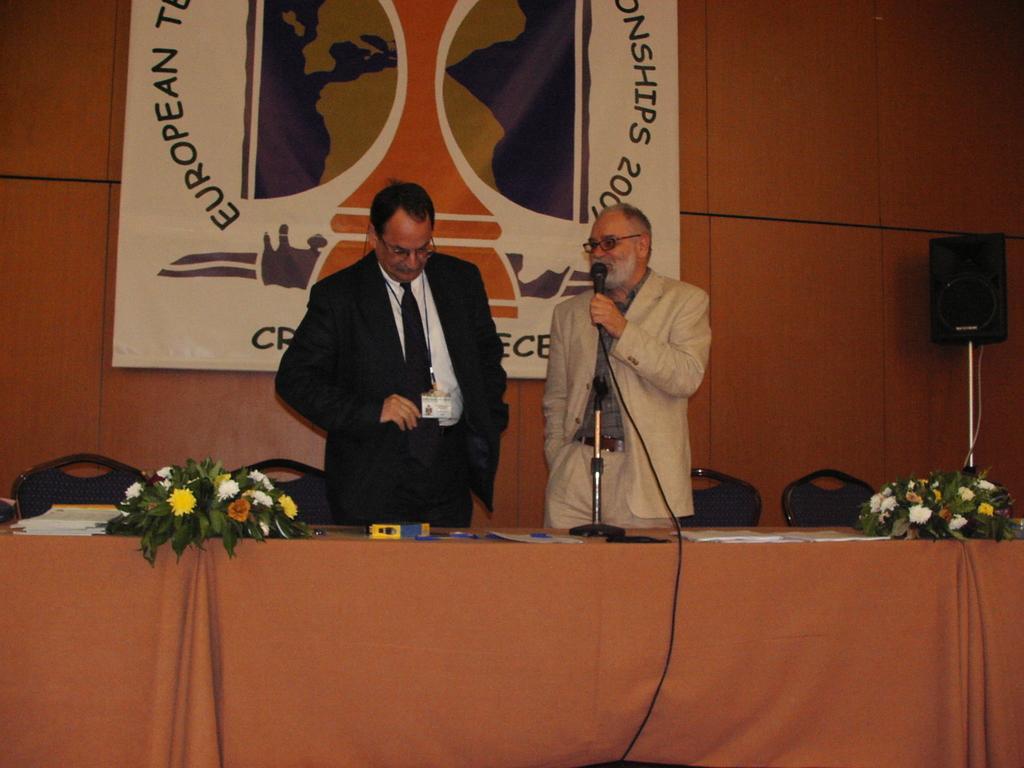Can you describe this image briefly? In this image I see 2 men, in which one of them is holding the mic and in front there are tables on which there are flowers. In the background I see the chairs, a speaker, wall and a banner. 